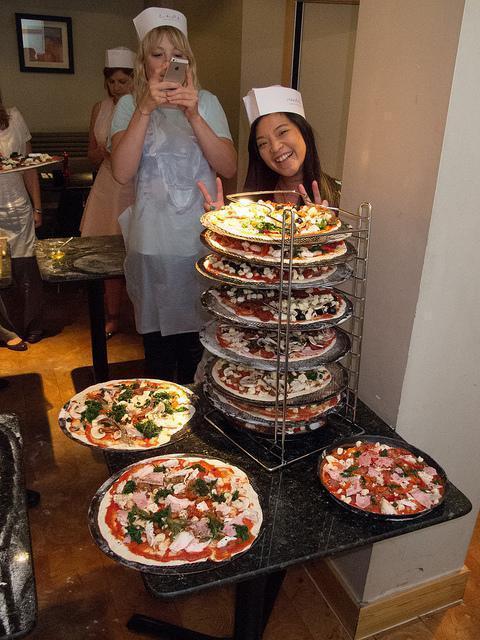What will these ladies next do with the pizzas?
Choose the right answer from the provided options to respond to the question.
Options: Bake, serve, throw away, eat. Bake. 